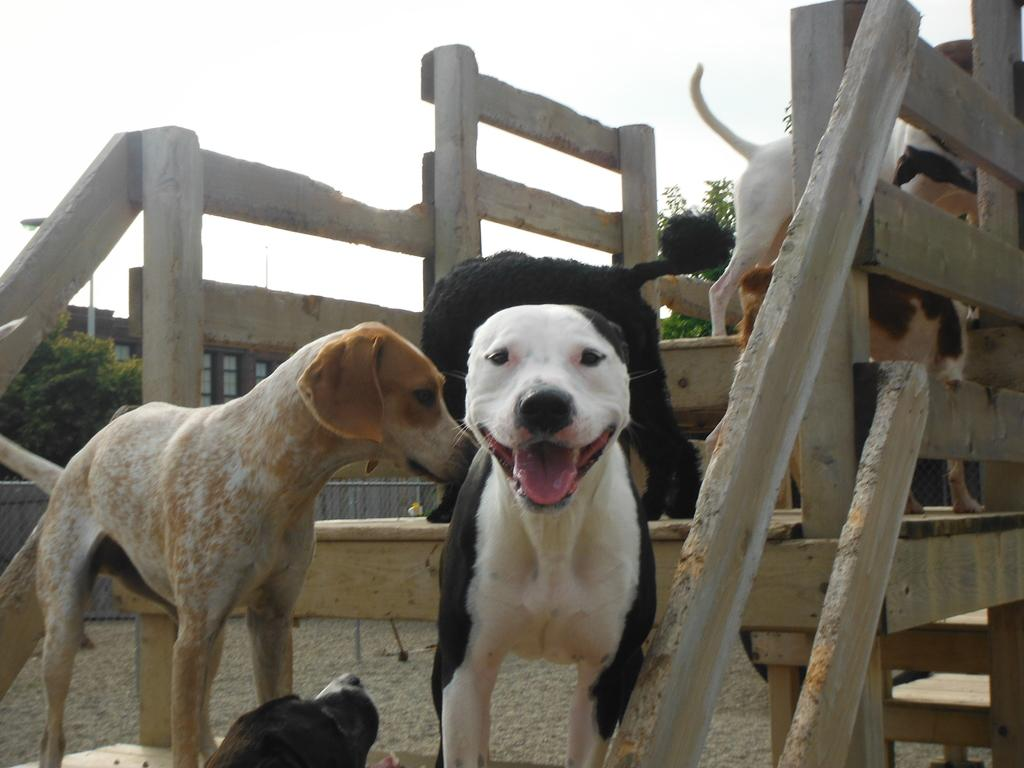What type of animals are present in the image? There are dogs in the image. What is the dogs' location in relation to the fence? The dogs are inside a fence. What can be seen in the background of the image? There is a building in the background of the image. What is located in front of the building? There is a tree in front of the building. What is visible above the building? The sky is visible above the building. What type of punishment is being administered to the dogs in the image? There is no indication of punishment in the image; the dogs are simply inside a fence. Can you see a crown on the tree in the image? There is no crown present in the image; the tree is a natural element without any adornments. 